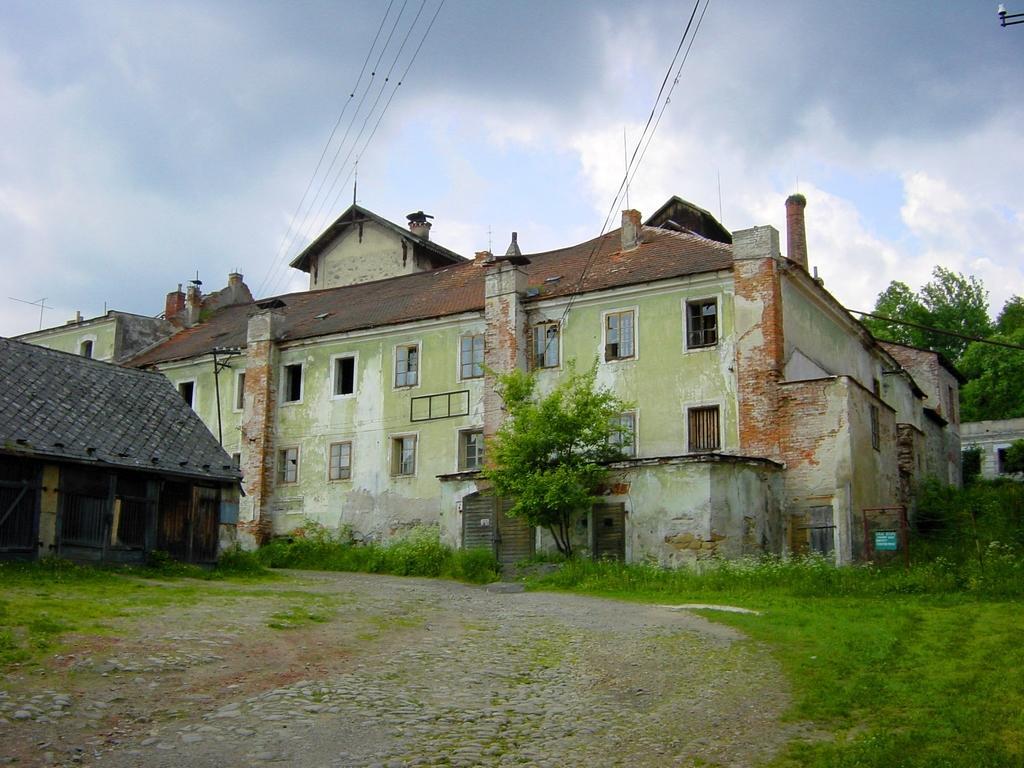Could you give a brief overview of what you see in this image? As we can see in the image there are buildings, grass and trees. On the top there is sky. 